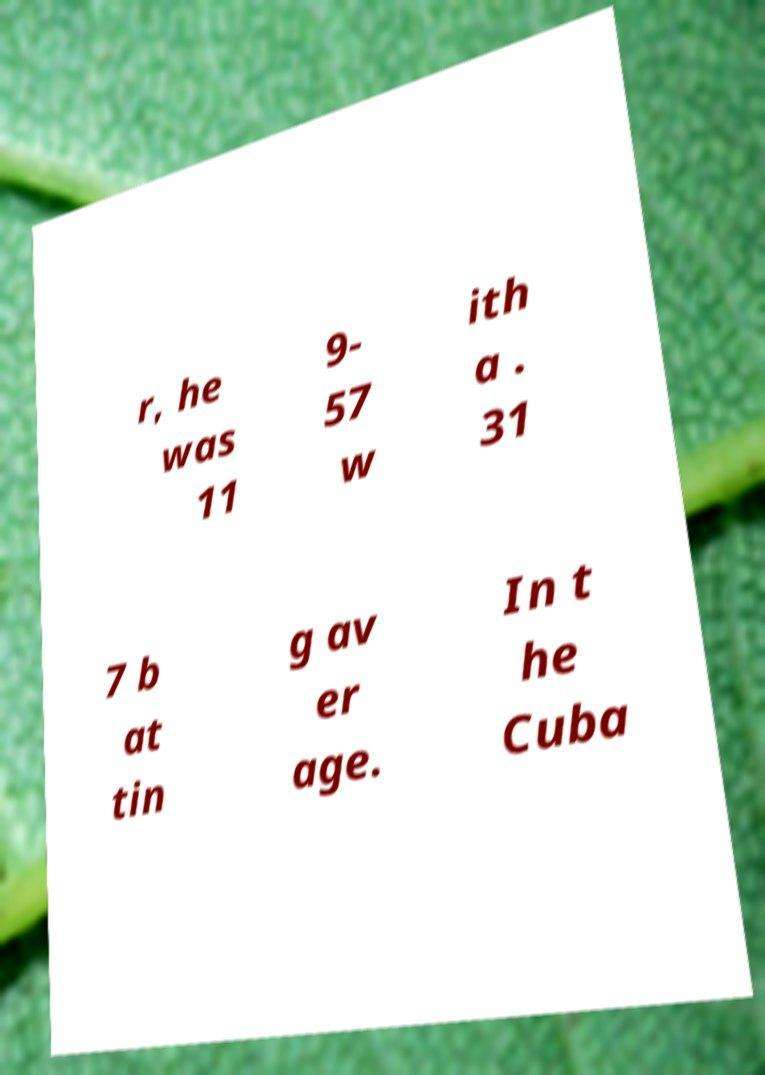Please identify and transcribe the text found in this image. r, he was 11 9- 57 w ith a . 31 7 b at tin g av er age. In t he Cuba 